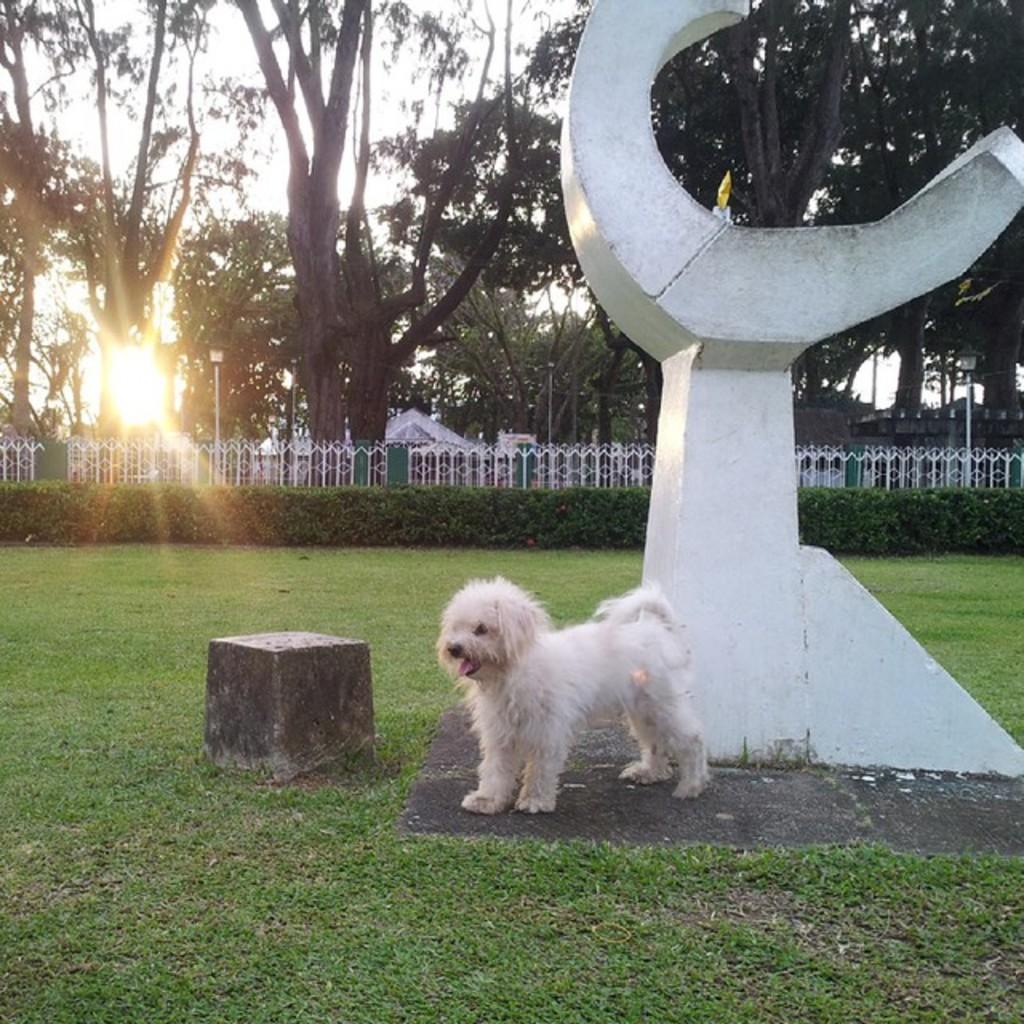Could you give a brief overview of what you see in this image? In this image we can see a dog on the ground. To the right side of the image we can see a statue. In the background, we can see a fence, group of poles, trees and the sky. 